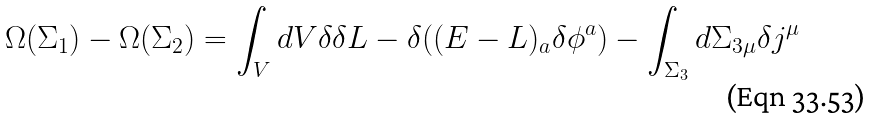Convert formula to latex. <formula><loc_0><loc_0><loc_500><loc_500>\Omega ( \Sigma _ { 1 } ) - \Omega ( \Sigma _ { 2 } ) = \int _ { V } d V \delta \delta L - \delta ( ( E - L ) _ { a } \delta { \phi ^ { a } } ) - \int _ { \Sigma _ { 3 } } d \Sigma _ { 3 \mu } \delta j ^ { \mu }</formula> 